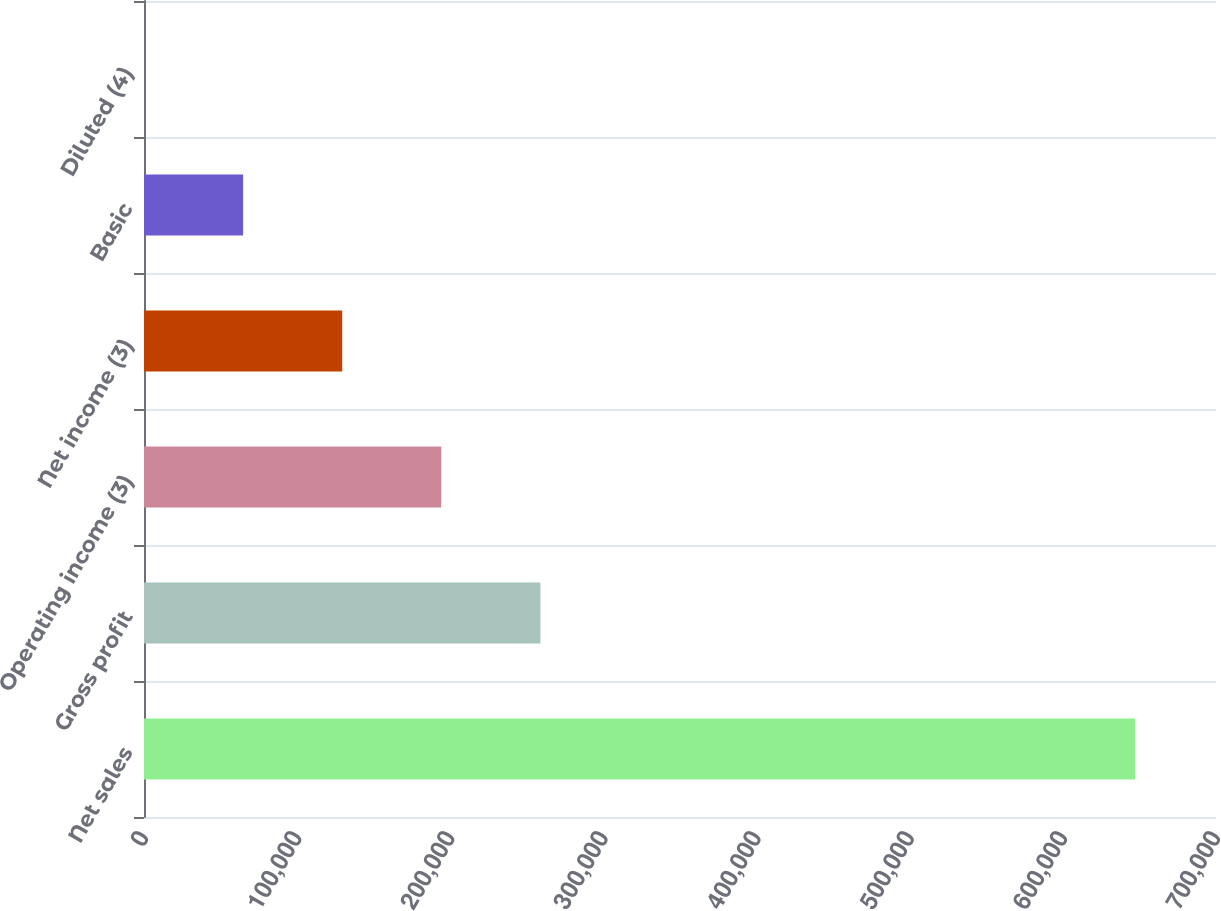Convert chart to OTSL. <chart><loc_0><loc_0><loc_500><loc_500><bar_chart><fcel>Net sales<fcel>Gross profit<fcel>Operating income (3)<fcel>Net income (3)<fcel>Basic<fcel>Diluted (4)<nl><fcel>647093<fcel>258837<fcel>194128<fcel>129419<fcel>64709.7<fcel>0.45<nl></chart> 